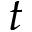<formula> <loc_0><loc_0><loc_500><loc_500>t</formula> 